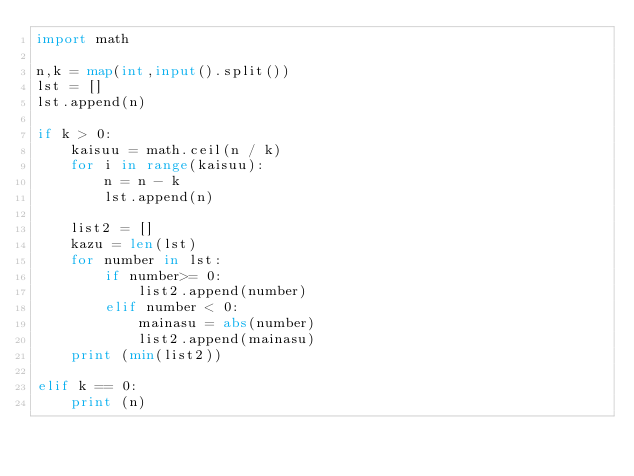Convert code to text. <code><loc_0><loc_0><loc_500><loc_500><_Python_>import math
 
n,k = map(int,input().split())
lst = []
lst.append(n)

if k > 0:
    kaisuu = math.ceil(n / k)
    for i in range(kaisuu):
        n = n - k
        lst.append(n)

    list2 = []
    kazu = len(lst)
    for number in lst:
        if number>= 0:
            list2.append(number)
        elif number < 0:
            mainasu = abs(number)
            list2.append(mainasu)
    print (min(list2))
    
elif k == 0:
    print (n)</code> 